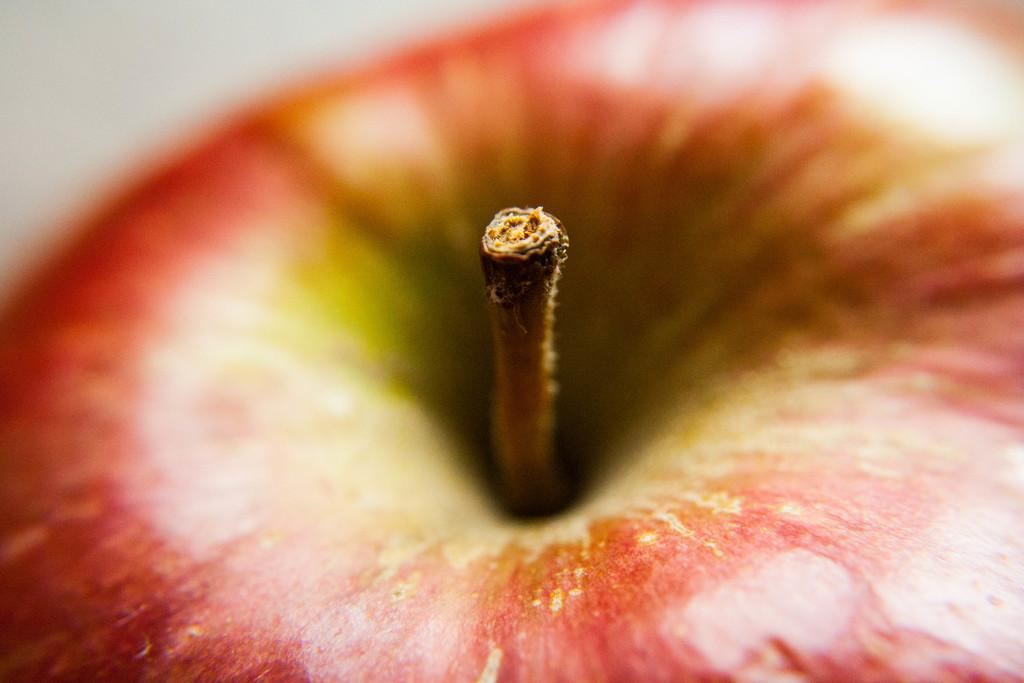What fruit is present in the image? There is an apple in the image. Can you describe the color of the apple? The apple has red and green colors. What part of the apple is visible in the image? There is a stem on the apple. What type of cart is visible in the image? There is no cart present in the image; it only features an apple. 